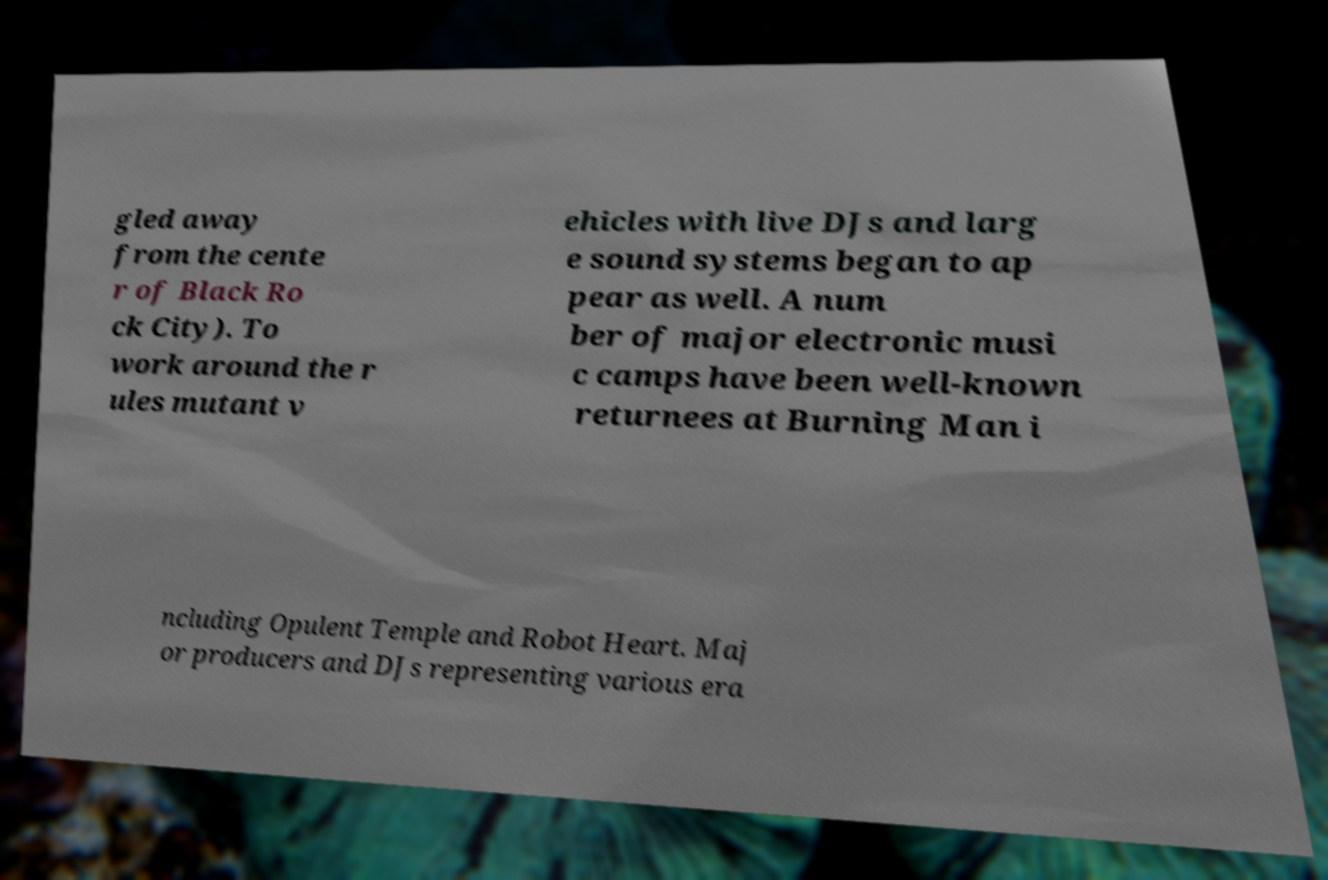I need the written content from this picture converted into text. Can you do that? gled away from the cente r of Black Ro ck City). To work around the r ules mutant v ehicles with live DJs and larg e sound systems began to ap pear as well. A num ber of major electronic musi c camps have been well-known returnees at Burning Man i ncluding Opulent Temple and Robot Heart. Maj or producers and DJs representing various era 